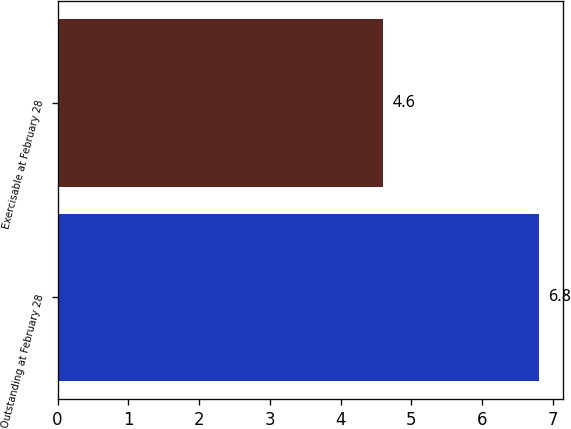Convert chart to OTSL. <chart><loc_0><loc_0><loc_500><loc_500><bar_chart><fcel>Outstanding at February 28<fcel>Exercisable at February 28<nl><fcel>6.8<fcel>4.6<nl></chart> 